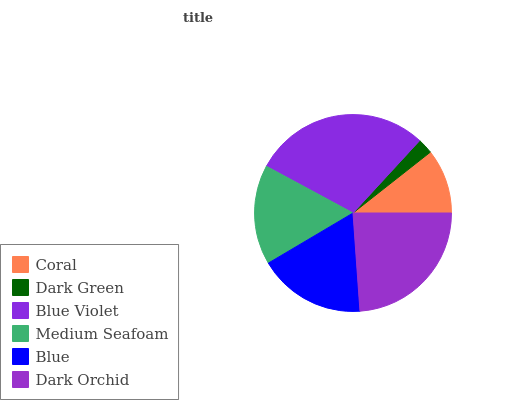Is Dark Green the minimum?
Answer yes or no. Yes. Is Blue Violet the maximum?
Answer yes or no. Yes. Is Blue Violet the minimum?
Answer yes or no. No. Is Dark Green the maximum?
Answer yes or no. No. Is Blue Violet greater than Dark Green?
Answer yes or no. Yes. Is Dark Green less than Blue Violet?
Answer yes or no. Yes. Is Dark Green greater than Blue Violet?
Answer yes or no. No. Is Blue Violet less than Dark Green?
Answer yes or no. No. Is Blue the high median?
Answer yes or no. Yes. Is Medium Seafoam the low median?
Answer yes or no. Yes. Is Coral the high median?
Answer yes or no. No. Is Blue Violet the low median?
Answer yes or no. No. 